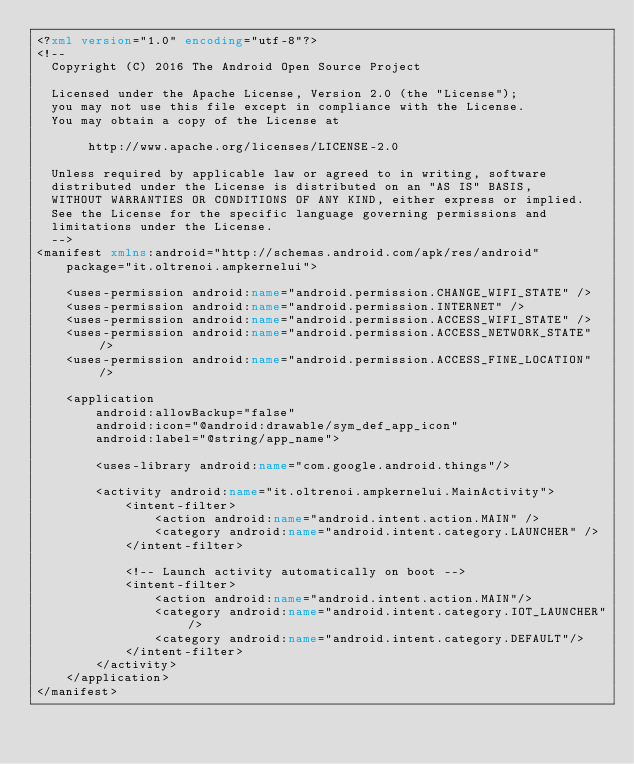Convert code to text. <code><loc_0><loc_0><loc_500><loc_500><_XML_><?xml version="1.0" encoding="utf-8"?>
<!--
  Copyright (C) 2016 The Android Open Source Project

  Licensed under the Apache License, Version 2.0 (the "License");
  you may not use this file except in compliance with the License.
  You may obtain a copy of the License at

       http://www.apache.org/licenses/LICENSE-2.0

  Unless required by applicable law or agreed to in writing, software
  distributed under the License is distributed on an "AS IS" BASIS,
  WITHOUT WARRANTIES OR CONDITIONS OF ANY KIND, either express or implied.
  See the License for the specific language governing permissions and
  limitations under the License.
  -->
<manifest xmlns:android="http://schemas.android.com/apk/res/android"
    package="it.oltrenoi.ampkernelui">

    <uses-permission android:name="android.permission.CHANGE_WIFI_STATE" />
    <uses-permission android:name="android.permission.INTERNET" />
    <uses-permission android:name="android.permission.ACCESS_WIFI_STATE" />
    <uses-permission android:name="android.permission.ACCESS_NETWORK_STATE" />
    <uses-permission android:name="android.permission.ACCESS_FINE_LOCATION" />

    <application
        android:allowBackup="false"
        android:icon="@android:drawable/sym_def_app_icon"
        android:label="@string/app_name">

        <uses-library android:name="com.google.android.things"/>

        <activity android:name="it.oltrenoi.ampkernelui.MainActivity">
            <intent-filter>
                <action android:name="android.intent.action.MAIN" />
                <category android:name="android.intent.category.LAUNCHER" />
            </intent-filter>

            <!-- Launch activity automatically on boot -->
            <intent-filter>
                <action android:name="android.intent.action.MAIN"/>
                <category android:name="android.intent.category.IOT_LAUNCHER"/>
                <category android:name="android.intent.category.DEFAULT"/>
            </intent-filter>
        </activity>
    </application>
</manifest>
</code> 